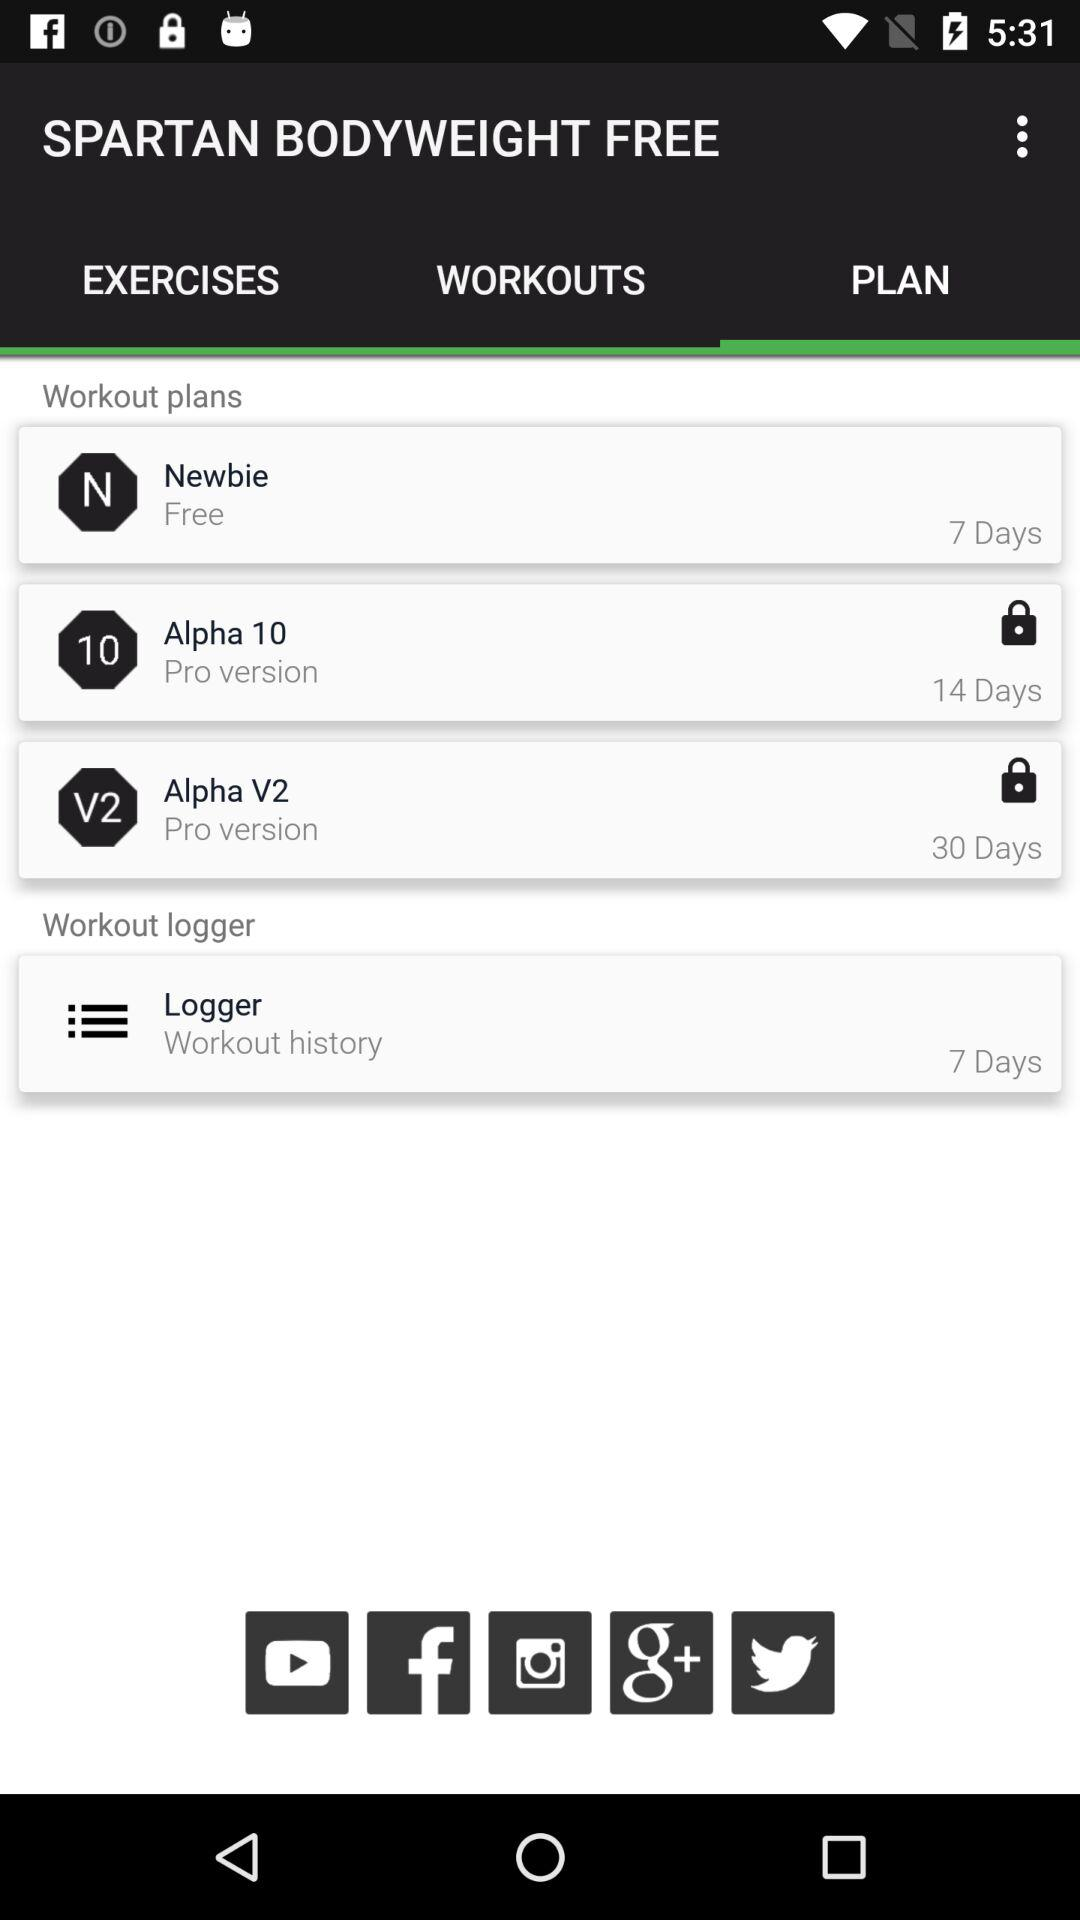How many workout plans are there?
Answer the question using a single word or phrase. 3 